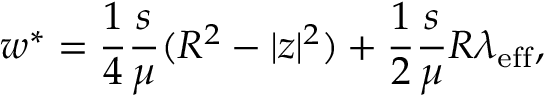<formula> <loc_0><loc_0><loc_500><loc_500>w ^ { * } = \frac { 1 } { 4 } \frac { s } { \mu } ( R ^ { 2 } - | z | ^ { 2 } ) + \frac { 1 } { 2 } \frac { s } { \mu } R \lambda _ { e f f } ,</formula> 